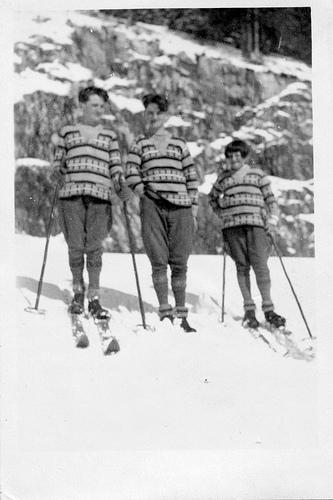Question: what is on their feet?
Choices:
A. Skis.
B. Running shoes.
C. Sneakers.
D. Snowboard.
Answer with the letter. Answer: A Question: where are these people?
Choices:
A. In jail.
B. Spelunking in a cave.
C. Ski slope.
D. At a riot.
Answer with the letter. Answer: C Question: what are they doing?
Choices:
A. Skiing.
B. Eating.
C. Kissing.
D. Dancing a polka.
Answer with the letter. Answer: A Question: why are they wearing sweaters?
Choices:
A. It is a part of their uniform.
B. It's cold.
C. They are models in a photography session.
D. They have no other available shirts or tops.
Answer with the letter. Answer: B Question: what are they holding?
Choices:
A. Live grenades.
B. Puppies.
C. Ski poles.
D. Corn dogs.
Answer with the letter. Answer: C Question: how many men are in the picture?
Choices:
A. Three.
B. Four.
C. Five.
D. Two.
Answer with the letter. Answer: D Question: how many women are in the picture?
Choices:
A. Two.
B. Three.
C. One.
D. Four.
Answer with the letter. Answer: C 